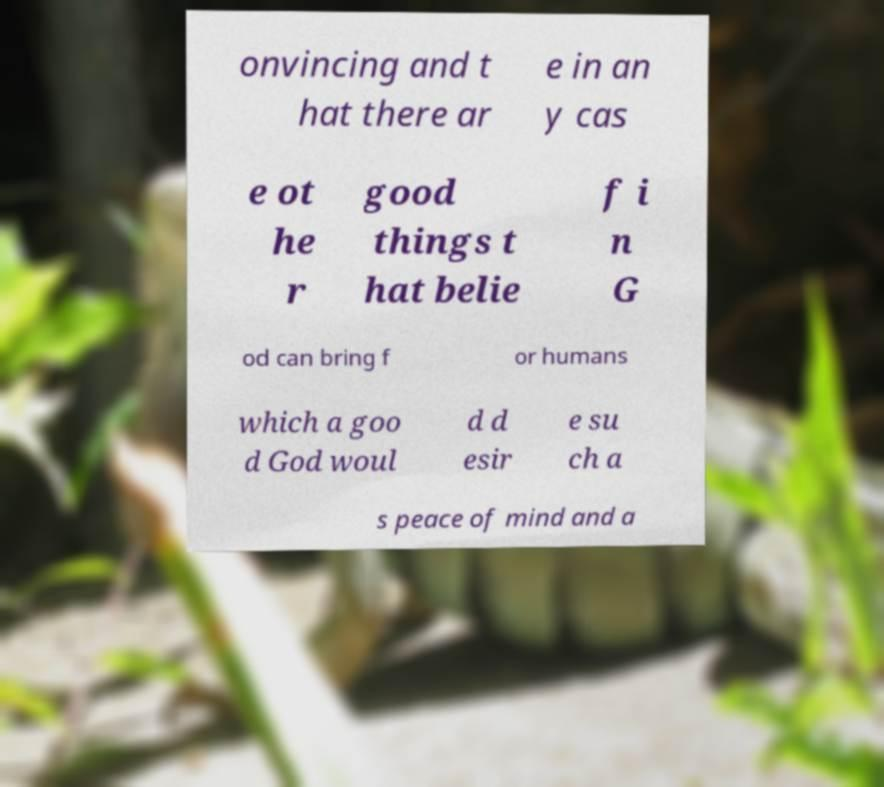Please identify and transcribe the text found in this image. onvincing and t hat there ar e in an y cas e ot he r good things t hat belie f i n G od can bring f or humans which a goo d God woul d d esir e su ch a s peace of mind and a 